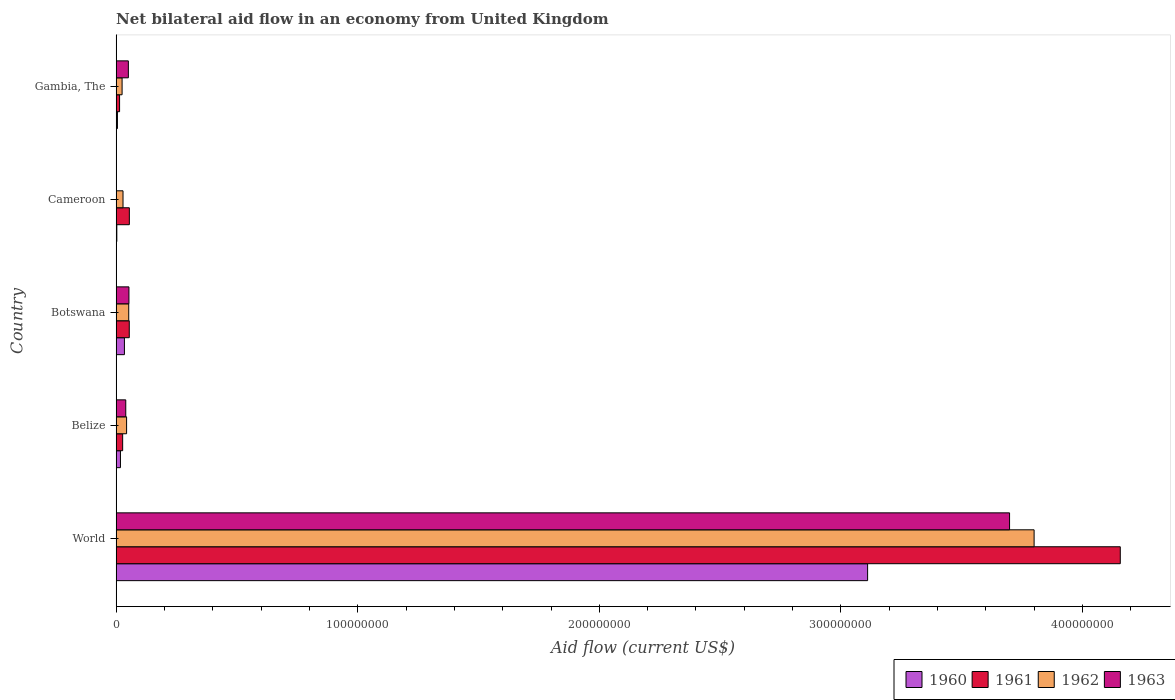How many groups of bars are there?
Keep it short and to the point. 5. Are the number of bars on each tick of the Y-axis equal?
Give a very brief answer. No. What is the label of the 2nd group of bars from the top?
Keep it short and to the point. Cameroon. What is the net bilateral aid flow in 1960 in Cameroon?
Give a very brief answer. 2.90e+05. Across all countries, what is the maximum net bilateral aid flow in 1961?
Give a very brief answer. 4.16e+08. Across all countries, what is the minimum net bilateral aid flow in 1962?
Offer a terse response. 2.47e+06. What is the total net bilateral aid flow in 1962 in the graph?
Offer a very short reply. 3.95e+08. What is the difference between the net bilateral aid flow in 1963 in Belize and that in World?
Ensure brevity in your answer.  -3.66e+08. What is the difference between the net bilateral aid flow in 1962 in Botswana and the net bilateral aid flow in 1963 in Gambia, The?
Give a very brief answer. 1.60e+05. What is the average net bilateral aid flow in 1963 per country?
Make the answer very short. 7.68e+07. What is the difference between the net bilateral aid flow in 1960 and net bilateral aid flow in 1962 in World?
Provide a succinct answer. -6.89e+07. What is the ratio of the net bilateral aid flow in 1960 in Belize to that in Botswana?
Make the answer very short. 0.52. Is the net bilateral aid flow in 1962 in Belize less than that in World?
Provide a short and direct response. Yes. What is the difference between the highest and the second highest net bilateral aid flow in 1960?
Offer a very short reply. 3.08e+08. What is the difference between the highest and the lowest net bilateral aid flow in 1960?
Your answer should be compact. 3.11e+08. In how many countries, is the net bilateral aid flow in 1960 greater than the average net bilateral aid flow in 1960 taken over all countries?
Keep it short and to the point. 1. Is the sum of the net bilateral aid flow in 1960 in Botswana and Cameroon greater than the maximum net bilateral aid flow in 1963 across all countries?
Offer a very short reply. No. Is it the case that in every country, the sum of the net bilateral aid flow in 1961 and net bilateral aid flow in 1963 is greater than the net bilateral aid flow in 1960?
Make the answer very short. Yes. How many bars are there?
Ensure brevity in your answer.  19. What is the difference between two consecutive major ticks on the X-axis?
Your answer should be very brief. 1.00e+08. Are the values on the major ticks of X-axis written in scientific E-notation?
Your answer should be very brief. No. Where does the legend appear in the graph?
Keep it short and to the point. Bottom right. How are the legend labels stacked?
Provide a succinct answer. Horizontal. What is the title of the graph?
Give a very brief answer. Net bilateral aid flow in an economy from United Kingdom. What is the label or title of the X-axis?
Keep it short and to the point. Aid flow (current US$). What is the label or title of the Y-axis?
Your answer should be compact. Country. What is the Aid flow (current US$) in 1960 in World?
Your response must be concise. 3.11e+08. What is the Aid flow (current US$) in 1961 in World?
Your answer should be compact. 4.16e+08. What is the Aid flow (current US$) of 1962 in World?
Ensure brevity in your answer.  3.80e+08. What is the Aid flow (current US$) of 1963 in World?
Offer a very short reply. 3.70e+08. What is the Aid flow (current US$) of 1960 in Belize?
Keep it short and to the point. 1.79e+06. What is the Aid flow (current US$) in 1961 in Belize?
Your response must be concise. 2.70e+06. What is the Aid flow (current US$) of 1962 in Belize?
Provide a short and direct response. 4.33e+06. What is the Aid flow (current US$) in 1963 in Belize?
Provide a short and direct response. 3.99e+06. What is the Aid flow (current US$) in 1960 in Botswana?
Offer a very short reply. 3.43e+06. What is the Aid flow (current US$) of 1961 in Botswana?
Offer a terse response. 5.44e+06. What is the Aid flow (current US$) of 1962 in Botswana?
Your answer should be very brief. 5.22e+06. What is the Aid flow (current US$) of 1963 in Botswana?
Give a very brief answer. 5.30e+06. What is the Aid flow (current US$) of 1960 in Cameroon?
Your answer should be very brief. 2.90e+05. What is the Aid flow (current US$) of 1961 in Cameroon?
Your response must be concise. 5.47e+06. What is the Aid flow (current US$) in 1962 in Cameroon?
Offer a very short reply. 2.85e+06. What is the Aid flow (current US$) of 1963 in Cameroon?
Keep it short and to the point. 0. What is the Aid flow (current US$) in 1960 in Gambia, The?
Ensure brevity in your answer.  5.40e+05. What is the Aid flow (current US$) in 1961 in Gambia, The?
Offer a very short reply. 1.43e+06. What is the Aid flow (current US$) of 1962 in Gambia, The?
Offer a terse response. 2.47e+06. What is the Aid flow (current US$) of 1963 in Gambia, The?
Give a very brief answer. 5.06e+06. Across all countries, what is the maximum Aid flow (current US$) of 1960?
Ensure brevity in your answer.  3.11e+08. Across all countries, what is the maximum Aid flow (current US$) of 1961?
Offer a very short reply. 4.16e+08. Across all countries, what is the maximum Aid flow (current US$) in 1962?
Give a very brief answer. 3.80e+08. Across all countries, what is the maximum Aid flow (current US$) of 1963?
Your response must be concise. 3.70e+08. Across all countries, what is the minimum Aid flow (current US$) of 1960?
Offer a very short reply. 2.90e+05. Across all countries, what is the minimum Aid flow (current US$) of 1961?
Offer a terse response. 1.43e+06. Across all countries, what is the minimum Aid flow (current US$) in 1962?
Your answer should be compact. 2.47e+06. What is the total Aid flow (current US$) in 1960 in the graph?
Give a very brief answer. 3.17e+08. What is the total Aid flow (current US$) in 1961 in the graph?
Your answer should be very brief. 4.31e+08. What is the total Aid flow (current US$) in 1962 in the graph?
Make the answer very short. 3.95e+08. What is the total Aid flow (current US$) of 1963 in the graph?
Your answer should be compact. 3.84e+08. What is the difference between the Aid flow (current US$) in 1960 in World and that in Belize?
Offer a terse response. 3.09e+08. What is the difference between the Aid flow (current US$) in 1961 in World and that in Belize?
Your answer should be very brief. 4.13e+08. What is the difference between the Aid flow (current US$) of 1962 in World and that in Belize?
Keep it short and to the point. 3.76e+08. What is the difference between the Aid flow (current US$) in 1963 in World and that in Belize?
Keep it short and to the point. 3.66e+08. What is the difference between the Aid flow (current US$) in 1960 in World and that in Botswana?
Keep it short and to the point. 3.08e+08. What is the difference between the Aid flow (current US$) of 1961 in World and that in Botswana?
Ensure brevity in your answer.  4.10e+08. What is the difference between the Aid flow (current US$) in 1962 in World and that in Botswana?
Your response must be concise. 3.75e+08. What is the difference between the Aid flow (current US$) in 1963 in World and that in Botswana?
Offer a very short reply. 3.65e+08. What is the difference between the Aid flow (current US$) of 1960 in World and that in Cameroon?
Your response must be concise. 3.11e+08. What is the difference between the Aid flow (current US$) of 1961 in World and that in Cameroon?
Your response must be concise. 4.10e+08. What is the difference between the Aid flow (current US$) in 1962 in World and that in Cameroon?
Ensure brevity in your answer.  3.77e+08. What is the difference between the Aid flow (current US$) of 1960 in World and that in Gambia, The?
Your answer should be very brief. 3.11e+08. What is the difference between the Aid flow (current US$) of 1961 in World and that in Gambia, The?
Keep it short and to the point. 4.14e+08. What is the difference between the Aid flow (current US$) of 1962 in World and that in Gambia, The?
Keep it short and to the point. 3.78e+08. What is the difference between the Aid flow (current US$) in 1963 in World and that in Gambia, The?
Offer a very short reply. 3.65e+08. What is the difference between the Aid flow (current US$) in 1960 in Belize and that in Botswana?
Give a very brief answer. -1.64e+06. What is the difference between the Aid flow (current US$) of 1961 in Belize and that in Botswana?
Ensure brevity in your answer.  -2.74e+06. What is the difference between the Aid flow (current US$) of 1962 in Belize and that in Botswana?
Give a very brief answer. -8.90e+05. What is the difference between the Aid flow (current US$) of 1963 in Belize and that in Botswana?
Ensure brevity in your answer.  -1.31e+06. What is the difference between the Aid flow (current US$) of 1960 in Belize and that in Cameroon?
Your response must be concise. 1.50e+06. What is the difference between the Aid flow (current US$) in 1961 in Belize and that in Cameroon?
Offer a very short reply. -2.77e+06. What is the difference between the Aid flow (current US$) in 1962 in Belize and that in Cameroon?
Your answer should be compact. 1.48e+06. What is the difference between the Aid flow (current US$) in 1960 in Belize and that in Gambia, The?
Offer a very short reply. 1.25e+06. What is the difference between the Aid flow (current US$) in 1961 in Belize and that in Gambia, The?
Offer a terse response. 1.27e+06. What is the difference between the Aid flow (current US$) in 1962 in Belize and that in Gambia, The?
Offer a very short reply. 1.86e+06. What is the difference between the Aid flow (current US$) in 1963 in Belize and that in Gambia, The?
Your answer should be compact. -1.07e+06. What is the difference between the Aid flow (current US$) in 1960 in Botswana and that in Cameroon?
Offer a very short reply. 3.14e+06. What is the difference between the Aid flow (current US$) in 1962 in Botswana and that in Cameroon?
Offer a very short reply. 2.37e+06. What is the difference between the Aid flow (current US$) of 1960 in Botswana and that in Gambia, The?
Keep it short and to the point. 2.89e+06. What is the difference between the Aid flow (current US$) in 1961 in Botswana and that in Gambia, The?
Provide a short and direct response. 4.01e+06. What is the difference between the Aid flow (current US$) in 1962 in Botswana and that in Gambia, The?
Your response must be concise. 2.75e+06. What is the difference between the Aid flow (current US$) of 1963 in Botswana and that in Gambia, The?
Keep it short and to the point. 2.40e+05. What is the difference between the Aid flow (current US$) in 1960 in Cameroon and that in Gambia, The?
Offer a very short reply. -2.50e+05. What is the difference between the Aid flow (current US$) in 1961 in Cameroon and that in Gambia, The?
Your answer should be compact. 4.04e+06. What is the difference between the Aid flow (current US$) of 1960 in World and the Aid flow (current US$) of 1961 in Belize?
Your response must be concise. 3.08e+08. What is the difference between the Aid flow (current US$) in 1960 in World and the Aid flow (current US$) in 1962 in Belize?
Your response must be concise. 3.07e+08. What is the difference between the Aid flow (current US$) of 1960 in World and the Aid flow (current US$) of 1963 in Belize?
Your response must be concise. 3.07e+08. What is the difference between the Aid flow (current US$) in 1961 in World and the Aid flow (current US$) in 1962 in Belize?
Make the answer very short. 4.11e+08. What is the difference between the Aid flow (current US$) of 1961 in World and the Aid flow (current US$) of 1963 in Belize?
Your response must be concise. 4.12e+08. What is the difference between the Aid flow (current US$) in 1962 in World and the Aid flow (current US$) in 1963 in Belize?
Offer a very short reply. 3.76e+08. What is the difference between the Aid flow (current US$) of 1960 in World and the Aid flow (current US$) of 1961 in Botswana?
Provide a succinct answer. 3.06e+08. What is the difference between the Aid flow (current US$) in 1960 in World and the Aid flow (current US$) in 1962 in Botswana?
Your answer should be very brief. 3.06e+08. What is the difference between the Aid flow (current US$) of 1960 in World and the Aid flow (current US$) of 1963 in Botswana?
Your answer should be very brief. 3.06e+08. What is the difference between the Aid flow (current US$) of 1961 in World and the Aid flow (current US$) of 1962 in Botswana?
Your answer should be compact. 4.10e+08. What is the difference between the Aid flow (current US$) of 1961 in World and the Aid flow (current US$) of 1963 in Botswana?
Your answer should be very brief. 4.10e+08. What is the difference between the Aid flow (current US$) in 1962 in World and the Aid flow (current US$) in 1963 in Botswana?
Provide a short and direct response. 3.75e+08. What is the difference between the Aid flow (current US$) of 1960 in World and the Aid flow (current US$) of 1961 in Cameroon?
Offer a terse response. 3.06e+08. What is the difference between the Aid flow (current US$) in 1960 in World and the Aid flow (current US$) in 1962 in Cameroon?
Make the answer very short. 3.08e+08. What is the difference between the Aid flow (current US$) of 1961 in World and the Aid flow (current US$) of 1962 in Cameroon?
Offer a terse response. 4.13e+08. What is the difference between the Aid flow (current US$) of 1960 in World and the Aid flow (current US$) of 1961 in Gambia, The?
Make the answer very short. 3.10e+08. What is the difference between the Aid flow (current US$) in 1960 in World and the Aid flow (current US$) in 1962 in Gambia, The?
Make the answer very short. 3.09e+08. What is the difference between the Aid flow (current US$) of 1960 in World and the Aid flow (current US$) of 1963 in Gambia, The?
Provide a succinct answer. 3.06e+08. What is the difference between the Aid flow (current US$) in 1961 in World and the Aid flow (current US$) in 1962 in Gambia, The?
Offer a very short reply. 4.13e+08. What is the difference between the Aid flow (current US$) of 1961 in World and the Aid flow (current US$) of 1963 in Gambia, The?
Give a very brief answer. 4.11e+08. What is the difference between the Aid flow (current US$) of 1962 in World and the Aid flow (current US$) of 1963 in Gambia, The?
Give a very brief answer. 3.75e+08. What is the difference between the Aid flow (current US$) of 1960 in Belize and the Aid flow (current US$) of 1961 in Botswana?
Make the answer very short. -3.65e+06. What is the difference between the Aid flow (current US$) of 1960 in Belize and the Aid flow (current US$) of 1962 in Botswana?
Offer a terse response. -3.43e+06. What is the difference between the Aid flow (current US$) of 1960 in Belize and the Aid flow (current US$) of 1963 in Botswana?
Your answer should be very brief. -3.51e+06. What is the difference between the Aid flow (current US$) of 1961 in Belize and the Aid flow (current US$) of 1962 in Botswana?
Ensure brevity in your answer.  -2.52e+06. What is the difference between the Aid flow (current US$) of 1961 in Belize and the Aid flow (current US$) of 1963 in Botswana?
Keep it short and to the point. -2.60e+06. What is the difference between the Aid flow (current US$) of 1962 in Belize and the Aid flow (current US$) of 1963 in Botswana?
Your response must be concise. -9.70e+05. What is the difference between the Aid flow (current US$) of 1960 in Belize and the Aid flow (current US$) of 1961 in Cameroon?
Your answer should be compact. -3.68e+06. What is the difference between the Aid flow (current US$) in 1960 in Belize and the Aid flow (current US$) in 1962 in Cameroon?
Your answer should be compact. -1.06e+06. What is the difference between the Aid flow (current US$) of 1960 in Belize and the Aid flow (current US$) of 1962 in Gambia, The?
Provide a short and direct response. -6.80e+05. What is the difference between the Aid flow (current US$) in 1960 in Belize and the Aid flow (current US$) in 1963 in Gambia, The?
Your answer should be compact. -3.27e+06. What is the difference between the Aid flow (current US$) of 1961 in Belize and the Aid flow (current US$) of 1963 in Gambia, The?
Give a very brief answer. -2.36e+06. What is the difference between the Aid flow (current US$) of 1962 in Belize and the Aid flow (current US$) of 1963 in Gambia, The?
Offer a terse response. -7.30e+05. What is the difference between the Aid flow (current US$) in 1960 in Botswana and the Aid flow (current US$) in 1961 in Cameroon?
Your response must be concise. -2.04e+06. What is the difference between the Aid flow (current US$) of 1960 in Botswana and the Aid flow (current US$) of 1962 in Cameroon?
Keep it short and to the point. 5.80e+05. What is the difference between the Aid flow (current US$) of 1961 in Botswana and the Aid flow (current US$) of 1962 in Cameroon?
Ensure brevity in your answer.  2.59e+06. What is the difference between the Aid flow (current US$) of 1960 in Botswana and the Aid flow (current US$) of 1961 in Gambia, The?
Offer a terse response. 2.00e+06. What is the difference between the Aid flow (current US$) in 1960 in Botswana and the Aid flow (current US$) in 1962 in Gambia, The?
Make the answer very short. 9.60e+05. What is the difference between the Aid flow (current US$) of 1960 in Botswana and the Aid flow (current US$) of 1963 in Gambia, The?
Offer a terse response. -1.63e+06. What is the difference between the Aid flow (current US$) of 1961 in Botswana and the Aid flow (current US$) of 1962 in Gambia, The?
Provide a succinct answer. 2.97e+06. What is the difference between the Aid flow (current US$) in 1962 in Botswana and the Aid flow (current US$) in 1963 in Gambia, The?
Your answer should be very brief. 1.60e+05. What is the difference between the Aid flow (current US$) of 1960 in Cameroon and the Aid flow (current US$) of 1961 in Gambia, The?
Provide a succinct answer. -1.14e+06. What is the difference between the Aid flow (current US$) in 1960 in Cameroon and the Aid flow (current US$) in 1962 in Gambia, The?
Offer a terse response. -2.18e+06. What is the difference between the Aid flow (current US$) of 1960 in Cameroon and the Aid flow (current US$) of 1963 in Gambia, The?
Offer a terse response. -4.77e+06. What is the difference between the Aid flow (current US$) in 1961 in Cameroon and the Aid flow (current US$) in 1962 in Gambia, The?
Keep it short and to the point. 3.00e+06. What is the difference between the Aid flow (current US$) in 1961 in Cameroon and the Aid flow (current US$) in 1963 in Gambia, The?
Your answer should be compact. 4.10e+05. What is the difference between the Aid flow (current US$) of 1962 in Cameroon and the Aid flow (current US$) of 1963 in Gambia, The?
Give a very brief answer. -2.21e+06. What is the average Aid flow (current US$) in 1960 per country?
Offer a terse response. 6.34e+07. What is the average Aid flow (current US$) in 1961 per country?
Provide a short and direct response. 8.61e+07. What is the average Aid flow (current US$) of 1962 per country?
Offer a terse response. 7.90e+07. What is the average Aid flow (current US$) in 1963 per country?
Make the answer very short. 7.68e+07. What is the difference between the Aid flow (current US$) in 1960 and Aid flow (current US$) in 1961 in World?
Offer a terse response. -1.05e+08. What is the difference between the Aid flow (current US$) in 1960 and Aid flow (current US$) in 1962 in World?
Offer a very short reply. -6.89e+07. What is the difference between the Aid flow (current US$) of 1960 and Aid flow (current US$) of 1963 in World?
Offer a terse response. -5.88e+07. What is the difference between the Aid flow (current US$) of 1961 and Aid flow (current US$) of 1962 in World?
Provide a short and direct response. 3.57e+07. What is the difference between the Aid flow (current US$) of 1961 and Aid flow (current US$) of 1963 in World?
Offer a very short reply. 4.58e+07. What is the difference between the Aid flow (current US$) in 1962 and Aid flow (current US$) in 1963 in World?
Your answer should be compact. 1.02e+07. What is the difference between the Aid flow (current US$) in 1960 and Aid flow (current US$) in 1961 in Belize?
Keep it short and to the point. -9.10e+05. What is the difference between the Aid flow (current US$) of 1960 and Aid flow (current US$) of 1962 in Belize?
Your response must be concise. -2.54e+06. What is the difference between the Aid flow (current US$) in 1960 and Aid flow (current US$) in 1963 in Belize?
Make the answer very short. -2.20e+06. What is the difference between the Aid flow (current US$) in 1961 and Aid flow (current US$) in 1962 in Belize?
Offer a terse response. -1.63e+06. What is the difference between the Aid flow (current US$) in 1961 and Aid flow (current US$) in 1963 in Belize?
Provide a short and direct response. -1.29e+06. What is the difference between the Aid flow (current US$) of 1960 and Aid flow (current US$) of 1961 in Botswana?
Your answer should be compact. -2.01e+06. What is the difference between the Aid flow (current US$) in 1960 and Aid flow (current US$) in 1962 in Botswana?
Provide a succinct answer. -1.79e+06. What is the difference between the Aid flow (current US$) of 1960 and Aid flow (current US$) of 1963 in Botswana?
Your answer should be very brief. -1.87e+06. What is the difference between the Aid flow (current US$) in 1961 and Aid flow (current US$) in 1962 in Botswana?
Ensure brevity in your answer.  2.20e+05. What is the difference between the Aid flow (current US$) of 1962 and Aid flow (current US$) of 1963 in Botswana?
Offer a terse response. -8.00e+04. What is the difference between the Aid flow (current US$) of 1960 and Aid flow (current US$) of 1961 in Cameroon?
Ensure brevity in your answer.  -5.18e+06. What is the difference between the Aid flow (current US$) in 1960 and Aid flow (current US$) in 1962 in Cameroon?
Keep it short and to the point. -2.56e+06. What is the difference between the Aid flow (current US$) of 1961 and Aid flow (current US$) of 1962 in Cameroon?
Provide a succinct answer. 2.62e+06. What is the difference between the Aid flow (current US$) of 1960 and Aid flow (current US$) of 1961 in Gambia, The?
Your answer should be compact. -8.90e+05. What is the difference between the Aid flow (current US$) in 1960 and Aid flow (current US$) in 1962 in Gambia, The?
Ensure brevity in your answer.  -1.93e+06. What is the difference between the Aid flow (current US$) in 1960 and Aid flow (current US$) in 1963 in Gambia, The?
Offer a very short reply. -4.52e+06. What is the difference between the Aid flow (current US$) of 1961 and Aid flow (current US$) of 1962 in Gambia, The?
Provide a short and direct response. -1.04e+06. What is the difference between the Aid flow (current US$) of 1961 and Aid flow (current US$) of 1963 in Gambia, The?
Ensure brevity in your answer.  -3.63e+06. What is the difference between the Aid flow (current US$) of 1962 and Aid flow (current US$) of 1963 in Gambia, The?
Ensure brevity in your answer.  -2.59e+06. What is the ratio of the Aid flow (current US$) of 1960 in World to that in Belize?
Your answer should be very brief. 173.77. What is the ratio of the Aid flow (current US$) of 1961 in World to that in Belize?
Make the answer very short. 153.94. What is the ratio of the Aid flow (current US$) of 1962 in World to that in Belize?
Your answer should be compact. 87.75. What is the ratio of the Aid flow (current US$) of 1963 in World to that in Belize?
Provide a succinct answer. 92.68. What is the ratio of the Aid flow (current US$) of 1960 in World to that in Botswana?
Your answer should be compact. 90.69. What is the ratio of the Aid flow (current US$) in 1961 in World to that in Botswana?
Provide a succinct answer. 76.4. What is the ratio of the Aid flow (current US$) in 1962 in World to that in Botswana?
Give a very brief answer. 72.79. What is the ratio of the Aid flow (current US$) in 1963 in World to that in Botswana?
Make the answer very short. 69.78. What is the ratio of the Aid flow (current US$) of 1960 in World to that in Cameroon?
Ensure brevity in your answer.  1072.59. What is the ratio of the Aid flow (current US$) in 1961 in World to that in Cameroon?
Keep it short and to the point. 75.99. What is the ratio of the Aid flow (current US$) in 1962 in World to that in Cameroon?
Keep it short and to the point. 133.32. What is the ratio of the Aid flow (current US$) of 1960 in World to that in Gambia, The?
Provide a short and direct response. 576.02. What is the ratio of the Aid flow (current US$) of 1961 in World to that in Gambia, The?
Ensure brevity in your answer.  290.66. What is the ratio of the Aid flow (current US$) in 1962 in World to that in Gambia, The?
Offer a very short reply. 153.83. What is the ratio of the Aid flow (current US$) of 1963 in World to that in Gambia, The?
Provide a succinct answer. 73.08. What is the ratio of the Aid flow (current US$) of 1960 in Belize to that in Botswana?
Keep it short and to the point. 0.52. What is the ratio of the Aid flow (current US$) of 1961 in Belize to that in Botswana?
Provide a succinct answer. 0.5. What is the ratio of the Aid flow (current US$) in 1962 in Belize to that in Botswana?
Give a very brief answer. 0.83. What is the ratio of the Aid flow (current US$) of 1963 in Belize to that in Botswana?
Your answer should be compact. 0.75. What is the ratio of the Aid flow (current US$) in 1960 in Belize to that in Cameroon?
Offer a very short reply. 6.17. What is the ratio of the Aid flow (current US$) of 1961 in Belize to that in Cameroon?
Keep it short and to the point. 0.49. What is the ratio of the Aid flow (current US$) of 1962 in Belize to that in Cameroon?
Your response must be concise. 1.52. What is the ratio of the Aid flow (current US$) of 1960 in Belize to that in Gambia, The?
Offer a very short reply. 3.31. What is the ratio of the Aid flow (current US$) of 1961 in Belize to that in Gambia, The?
Provide a succinct answer. 1.89. What is the ratio of the Aid flow (current US$) of 1962 in Belize to that in Gambia, The?
Make the answer very short. 1.75. What is the ratio of the Aid flow (current US$) of 1963 in Belize to that in Gambia, The?
Make the answer very short. 0.79. What is the ratio of the Aid flow (current US$) in 1960 in Botswana to that in Cameroon?
Your answer should be very brief. 11.83. What is the ratio of the Aid flow (current US$) in 1962 in Botswana to that in Cameroon?
Offer a very short reply. 1.83. What is the ratio of the Aid flow (current US$) of 1960 in Botswana to that in Gambia, The?
Keep it short and to the point. 6.35. What is the ratio of the Aid flow (current US$) of 1961 in Botswana to that in Gambia, The?
Offer a very short reply. 3.8. What is the ratio of the Aid flow (current US$) in 1962 in Botswana to that in Gambia, The?
Make the answer very short. 2.11. What is the ratio of the Aid flow (current US$) of 1963 in Botswana to that in Gambia, The?
Provide a succinct answer. 1.05. What is the ratio of the Aid flow (current US$) in 1960 in Cameroon to that in Gambia, The?
Provide a short and direct response. 0.54. What is the ratio of the Aid flow (current US$) of 1961 in Cameroon to that in Gambia, The?
Make the answer very short. 3.83. What is the ratio of the Aid flow (current US$) of 1962 in Cameroon to that in Gambia, The?
Your response must be concise. 1.15. What is the difference between the highest and the second highest Aid flow (current US$) of 1960?
Your answer should be compact. 3.08e+08. What is the difference between the highest and the second highest Aid flow (current US$) of 1961?
Give a very brief answer. 4.10e+08. What is the difference between the highest and the second highest Aid flow (current US$) of 1962?
Ensure brevity in your answer.  3.75e+08. What is the difference between the highest and the second highest Aid flow (current US$) of 1963?
Offer a very short reply. 3.65e+08. What is the difference between the highest and the lowest Aid flow (current US$) in 1960?
Ensure brevity in your answer.  3.11e+08. What is the difference between the highest and the lowest Aid flow (current US$) in 1961?
Your answer should be very brief. 4.14e+08. What is the difference between the highest and the lowest Aid flow (current US$) of 1962?
Your answer should be very brief. 3.78e+08. What is the difference between the highest and the lowest Aid flow (current US$) of 1963?
Provide a short and direct response. 3.70e+08. 